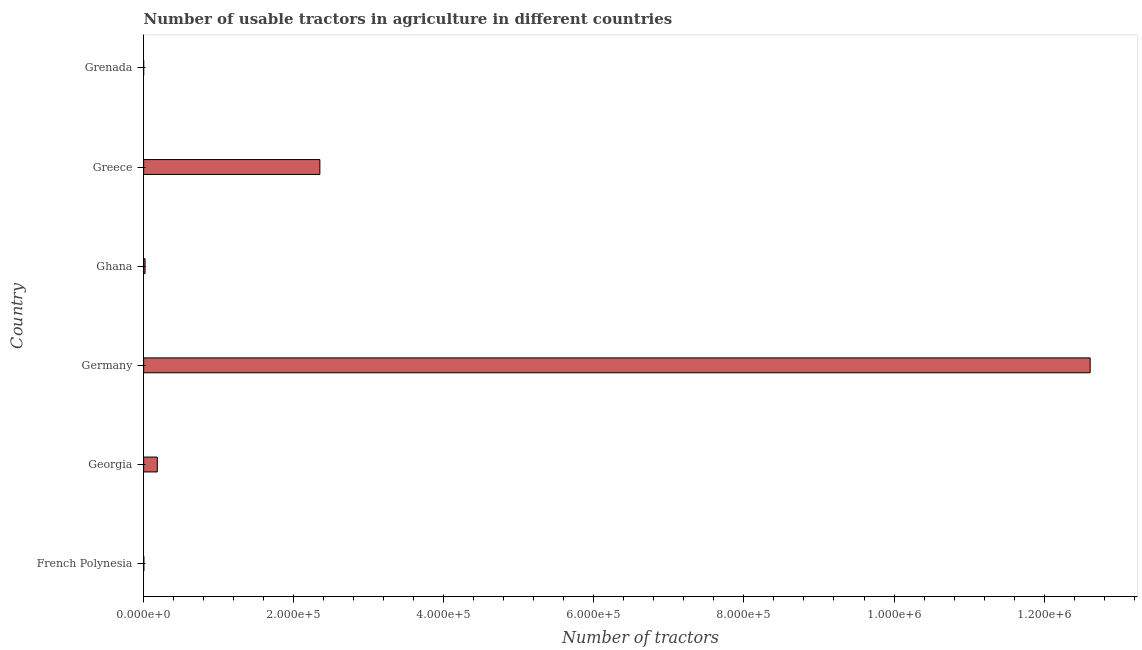Does the graph contain any zero values?
Provide a succinct answer. No. Does the graph contain grids?
Your answer should be very brief. No. What is the title of the graph?
Provide a short and direct response. Number of usable tractors in agriculture in different countries. What is the label or title of the X-axis?
Your answer should be very brief. Number of tractors. What is the label or title of the Y-axis?
Ensure brevity in your answer.  Country. What is the number of tractors in Georgia?
Offer a very short reply. 1.82e+04. Across all countries, what is the maximum number of tractors?
Offer a terse response. 1.26e+06. In which country was the number of tractors maximum?
Ensure brevity in your answer.  Germany. In which country was the number of tractors minimum?
Offer a very short reply. Grenada. What is the sum of the number of tractors?
Your answer should be compact. 1.52e+06. What is the difference between the number of tractors in Germany and Greece?
Ensure brevity in your answer.  1.03e+06. What is the average number of tractors per country?
Offer a very short reply. 2.53e+05. What is the median number of tractors?
Offer a very short reply. 1.00e+04. In how many countries, is the number of tractors greater than 1240000 ?
Provide a short and direct response. 1. What is the ratio of the number of tractors in Georgia to that in Greece?
Your response must be concise. 0.08. Is the difference between the number of tractors in Germany and Ghana greater than the difference between any two countries?
Keep it short and to the point. No. What is the difference between the highest and the second highest number of tractors?
Your answer should be very brief. 1.03e+06. Is the sum of the number of tractors in Ghana and Greece greater than the maximum number of tractors across all countries?
Your answer should be compact. No. What is the difference between the highest and the lowest number of tractors?
Offer a very short reply. 1.26e+06. Are all the bars in the graph horizontal?
Give a very brief answer. Yes. How many countries are there in the graph?
Offer a terse response. 6. What is the difference between two consecutive major ticks on the X-axis?
Your answer should be compact. 2.00e+05. What is the Number of tractors in French Polynesia?
Your response must be concise. 255. What is the Number of tractors in Georgia?
Provide a short and direct response. 1.82e+04. What is the Number of tractors of Germany?
Give a very brief answer. 1.26e+06. What is the Number of tractors in Ghana?
Offer a very short reply. 1892. What is the Number of tractors in Greece?
Ensure brevity in your answer.  2.35e+05. What is the Number of tractors of Grenada?
Keep it short and to the point. 13. What is the difference between the Number of tractors in French Polynesia and Georgia?
Your answer should be compact. -1.79e+04. What is the difference between the Number of tractors in French Polynesia and Germany?
Provide a succinct answer. -1.26e+06. What is the difference between the Number of tractors in French Polynesia and Ghana?
Make the answer very short. -1637. What is the difference between the Number of tractors in French Polynesia and Greece?
Keep it short and to the point. -2.35e+05. What is the difference between the Number of tractors in French Polynesia and Grenada?
Make the answer very short. 242. What is the difference between the Number of tractors in Georgia and Germany?
Provide a short and direct response. -1.24e+06. What is the difference between the Number of tractors in Georgia and Ghana?
Keep it short and to the point. 1.63e+04. What is the difference between the Number of tractors in Georgia and Greece?
Provide a succinct answer. -2.17e+05. What is the difference between the Number of tractors in Georgia and Grenada?
Your response must be concise. 1.82e+04. What is the difference between the Number of tractors in Germany and Ghana?
Your answer should be very brief. 1.26e+06. What is the difference between the Number of tractors in Germany and Greece?
Offer a very short reply. 1.03e+06. What is the difference between the Number of tractors in Germany and Grenada?
Ensure brevity in your answer.  1.26e+06. What is the difference between the Number of tractors in Ghana and Greece?
Offer a very short reply. -2.33e+05. What is the difference between the Number of tractors in Ghana and Grenada?
Your answer should be very brief. 1879. What is the difference between the Number of tractors in Greece and Grenada?
Ensure brevity in your answer.  2.35e+05. What is the ratio of the Number of tractors in French Polynesia to that in Georgia?
Provide a succinct answer. 0.01. What is the ratio of the Number of tractors in French Polynesia to that in Ghana?
Keep it short and to the point. 0.14. What is the ratio of the Number of tractors in French Polynesia to that in Grenada?
Give a very brief answer. 19.61. What is the ratio of the Number of tractors in Georgia to that in Germany?
Offer a very short reply. 0.01. What is the ratio of the Number of tractors in Georgia to that in Ghana?
Your answer should be compact. 9.62. What is the ratio of the Number of tractors in Georgia to that in Greece?
Keep it short and to the point. 0.08. What is the ratio of the Number of tractors in Georgia to that in Grenada?
Your response must be concise. 1400. What is the ratio of the Number of tractors in Germany to that in Ghana?
Make the answer very short. 666.7. What is the ratio of the Number of tractors in Germany to that in Greece?
Offer a very short reply. 5.37. What is the ratio of the Number of tractors in Germany to that in Grenada?
Your response must be concise. 9.70e+04. What is the ratio of the Number of tractors in Ghana to that in Greece?
Make the answer very short. 0.01. What is the ratio of the Number of tractors in Ghana to that in Grenada?
Offer a terse response. 145.54. What is the ratio of the Number of tractors in Greece to that in Grenada?
Give a very brief answer. 1.81e+04. 